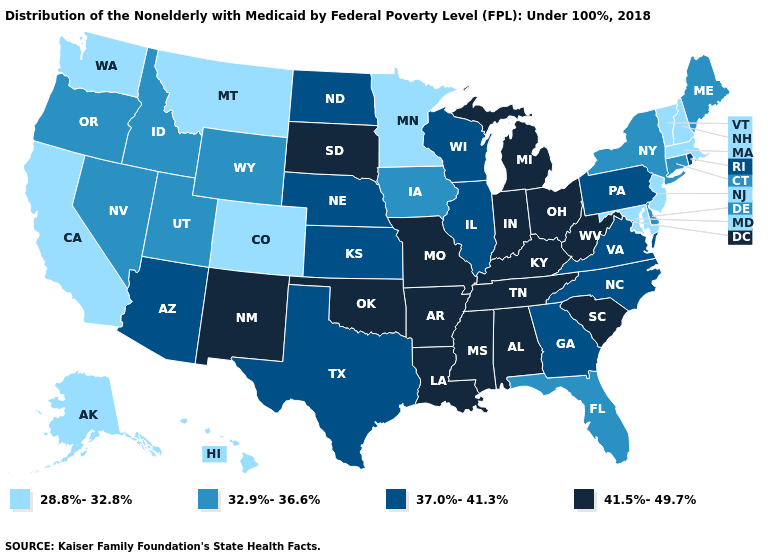Which states have the lowest value in the South?
Write a very short answer. Maryland. Is the legend a continuous bar?
Write a very short answer. No. Name the states that have a value in the range 28.8%-32.8%?
Give a very brief answer. Alaska, California, Colorado, Hawaii, Maryland, Massachusetts, Minnesota, Montana, New Hampshire, New Jersey, Vermont, Washington. Does Montana have the lowest value in the USA?
Concise answer only. Yes. Is the legend a continuous bar?
Write a very short answer. No. What is the lowest value in states that border Delaware?
Write a very short answer. 28.8%-32.8%. What is the highest value in states that border Utah?
Write a very short answer. 41.5%-49.7%. Name the states that have a value in the range 28.8%-32.8%?
Concise answer only. Alaska, California, Colorado, Hawaii, Maryland, Massachusetts, Minnesota, Montana, New Hampshire, New Jersey, Vermont, Washington. Does Rhode Island have the highest value in the Northeast?
Answer briefly. Yes. What is the value of Rhode Island?
Quick response, please. 37.0%-41.3%. What is the lowest value in states that border Maine?
Give a very brief answer. 28.8%-32.8%. Among the states that border Maine , which have the lowest value?
Concise answer only. New Hampshire. What is the highest value in the Northeast ?
Give a very brief answer. 37.0%-41.3%. What is the value of Rhode Island?
Write a very short answer. 37.0%-41.3%. Which states hav the highest value in the South?
Keep it brief. Alabama, Arkansas, Kentucky, Louisiana, Mississippi, Oklahoma, South Carolina, Tennessee, West Virginia. 